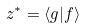<formula> <loc_0><loc_0><loc_500><loc_500>z ^ { * } = \langle g | f \rangle</formula> 